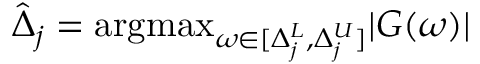<formula> <loc_0><loc_0><loc_500><loc_500>\hat { \Delta } _ { j } = \arg \max _ { \omega \in [ \Delta _ { j } ^ { L } , \Delta _ { j } ^ { U } ] } | G ( \omega ) |</formula> 